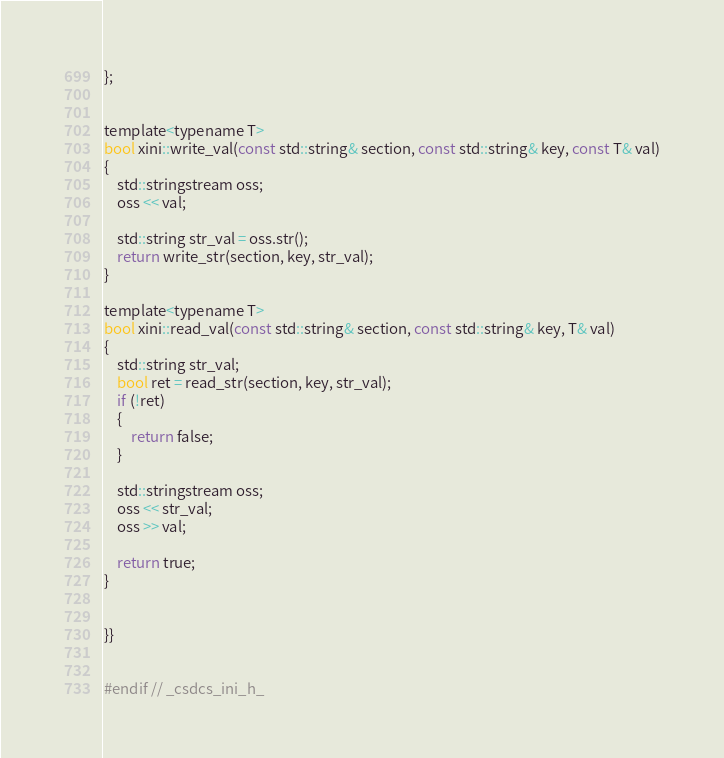<code> <loc_0><loc_0><loc_500><loc_500><_C_>};


template<typename T>
bool xini::write_val(const std::string& section, const std::string& key, const T& val)
{
    std::stringstream oss;
    oss << val;

    std::string str_val = oss.str();
    return write_str(section, key, str_val);
}

template<typename T>
bool xini::read_val(const std::string& section, const std::string& key, T& val)
{
    std::string str_val;
    bool ret = read_str(section, key, str_val);
    if (!ret)
    {
        return false;
    }

    std::stringstream oss;
    oss << str_val;
    oss >> val;

    return true;
}


}}


#endif // _csdcs_ini_h_

</code> 